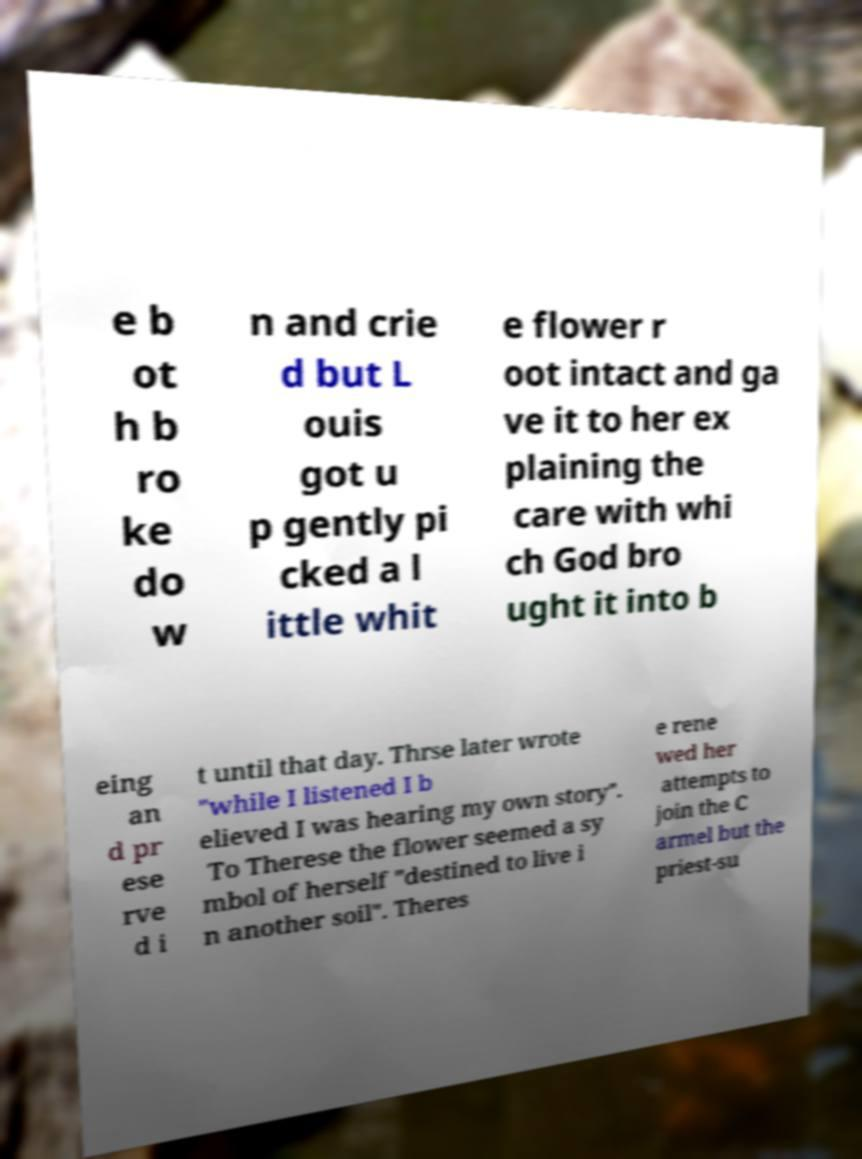Can you accurately transcribe the text from the provided image for me? e b ot h b ro ke do w n and crie d but L ouis got u p gently pi cked a l ittle whit e flower r oot intact and ga ve it to her ex plaining the care with whi ch God bro ught it into b eing an d pr ese rve d i t until that day. Thrse later wrote "while I listened I b elieved I was hearing my own story". To Therese the flower seemed a sy mbol of herself "destined to live i n another soil". Theres e rene wed her attempts to join the C armel but the priest-su 